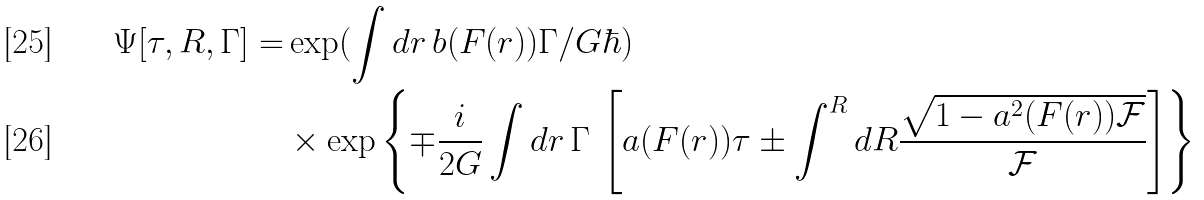Convert formula to latex. <formula><loc_0><loc_0><loc_500><loc_500>\Psi [ \tau , R , \Gamma ] = & \exp ( \int d r \, b ( F ( r ) ) \Gamma / G \hbar { ) } \, \\ & \times \exp \left \{ \mp \frac { i } { 2 G } \int d r \, \Gamma \, \left [ a ( F ( r ) ) \tau \pm \int ^ { R } d R \frac { \sqrt { 1 - a ^ { 2 } ( F ( r ) ) \mathcal { F } } } { \mathcal { F } } \right ] \right \} \,</formula> 